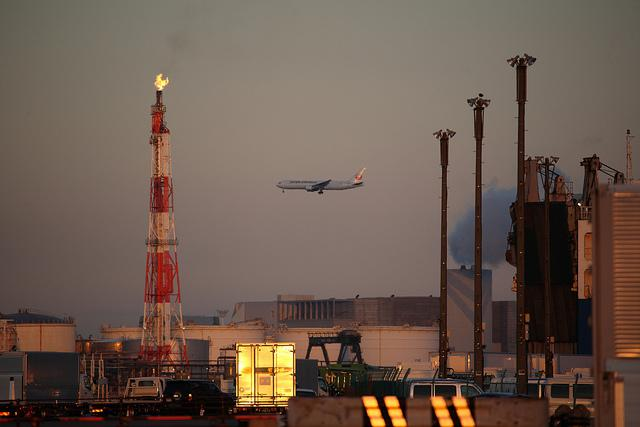What is coming out of the red and white tower?

Choices:
A) water
B) smoke
C) people
D) fire fire 